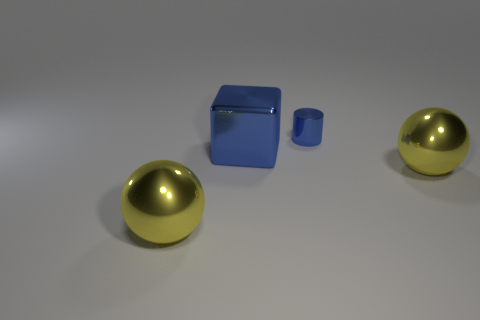Do the ball that is left of the metal cube and the yellow object that is to the right of the tiny blue shiny cylinder have the same material?
Your answer should be very brief. Yes. There is a ball that is on the left side of the small blue metallic cylinder that is behind the metallic thing that is left of the large blue metal thing; what color is it?
Offer a very short reply. Yellow. How many other things are there of the same shape as the small blue object?
Ensure brevity in your answer.  0. Do the big block and the small metal cylinder have the same color?
Your response must be concise. Yes. How many objects are big spheres or large spheres on the left side of the blue cylinder?
Offer a terse response. 2. Is there a red metallic cylinder that has the same size as the cube?
Offer a very short reply. No. Is the tiny thing made of the same material as the large cube?
Your answer should be very brief. Yes. How many objects are spheres or small blue things?
Your response must be concise. 3. The blue metal cylinder is what size?
Give a very brief answer. Small. Is the number of blue rubber spheres less than the number of blue metallic blocks?
Offer a terse response. Yes. 